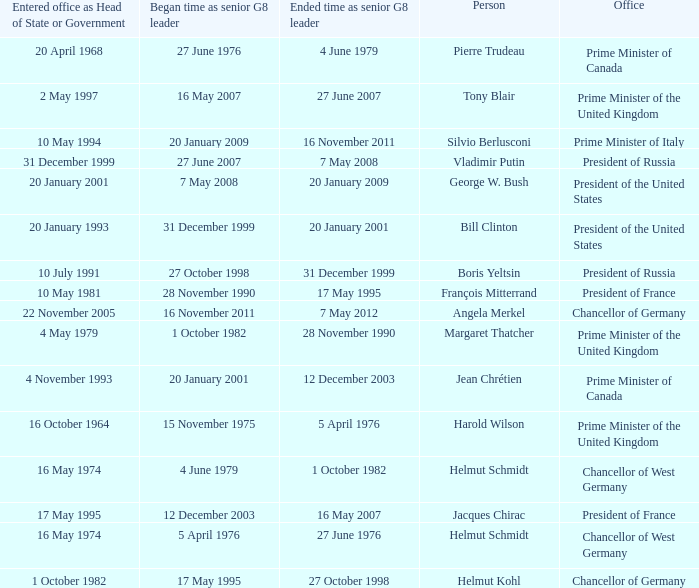When did the Prime Minister of Italy take office? 10 May 1994. 